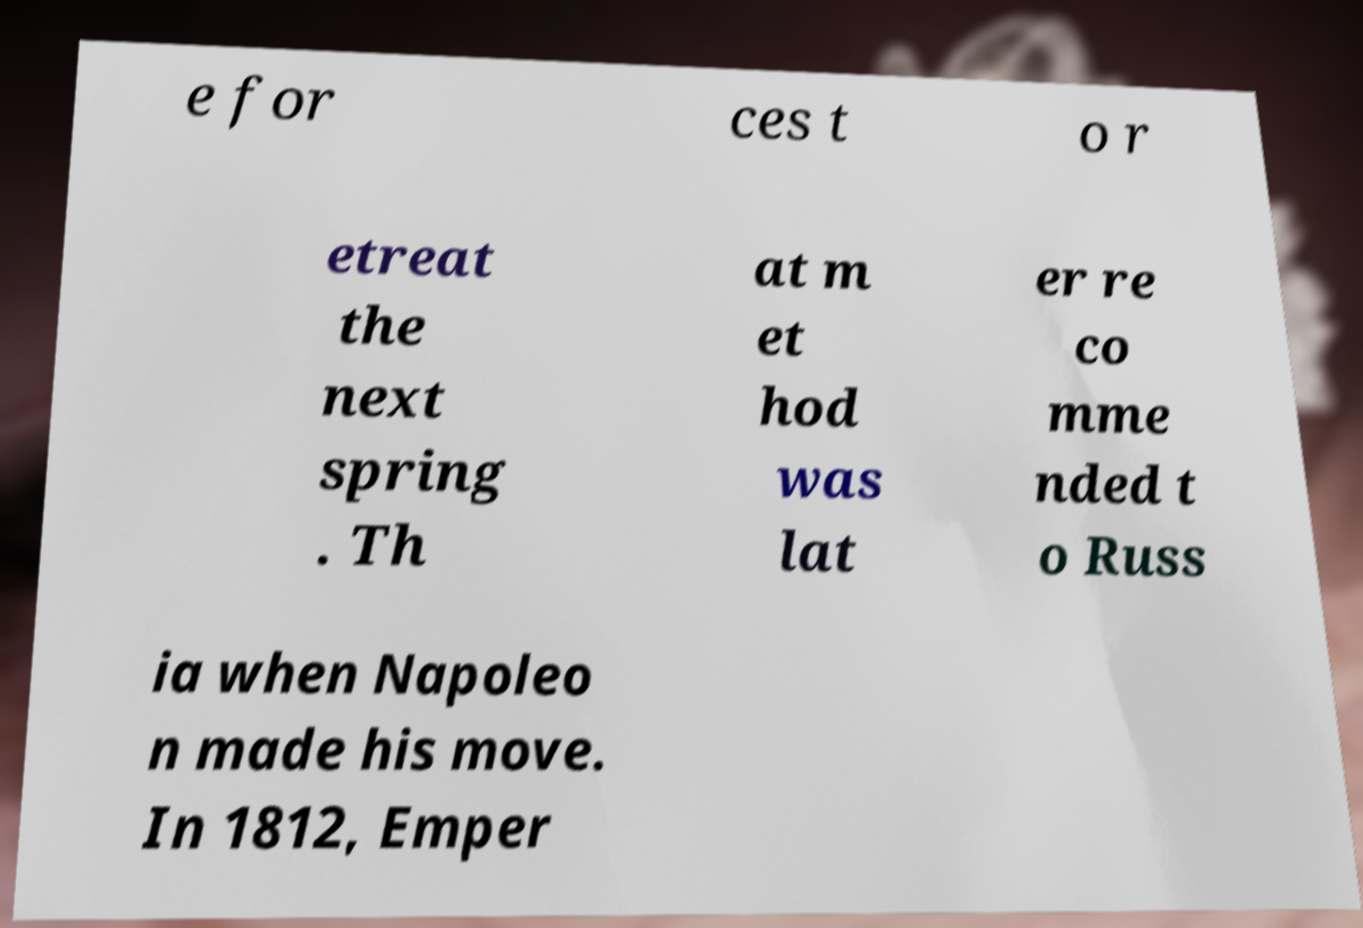Can you accurately transcribe the text from the provided image for me? e for ces t o r etreat the next spring . Th at m et hod was lat er re co mme nded t o Russ ia when Napoleo n made his move. In 1812, Emper 